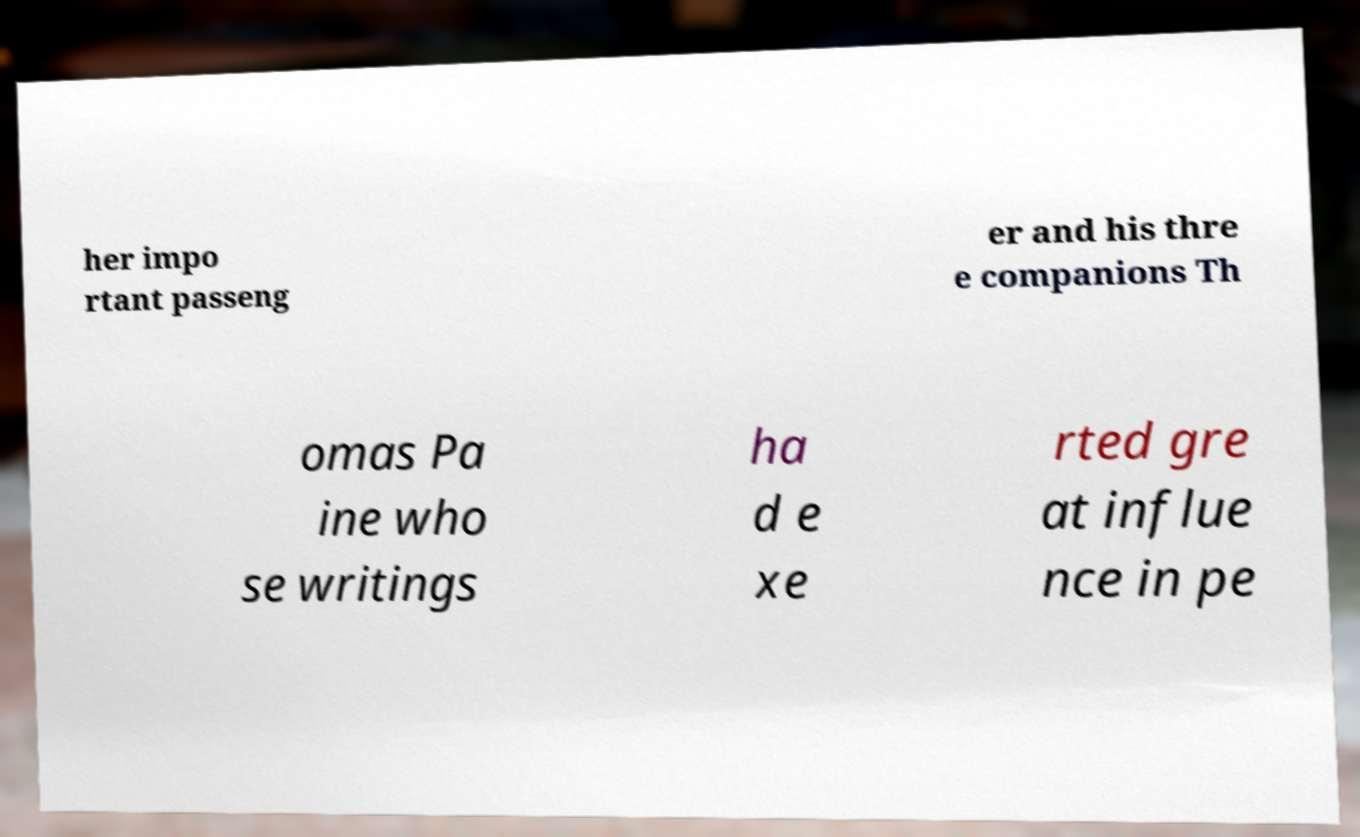I need the written content from this picture converted into text. Can you do that? her impo rtant passeng er and his thre e companions Th omas Pa ine who se writings ha d e xe rted gre at influe nce in pe 